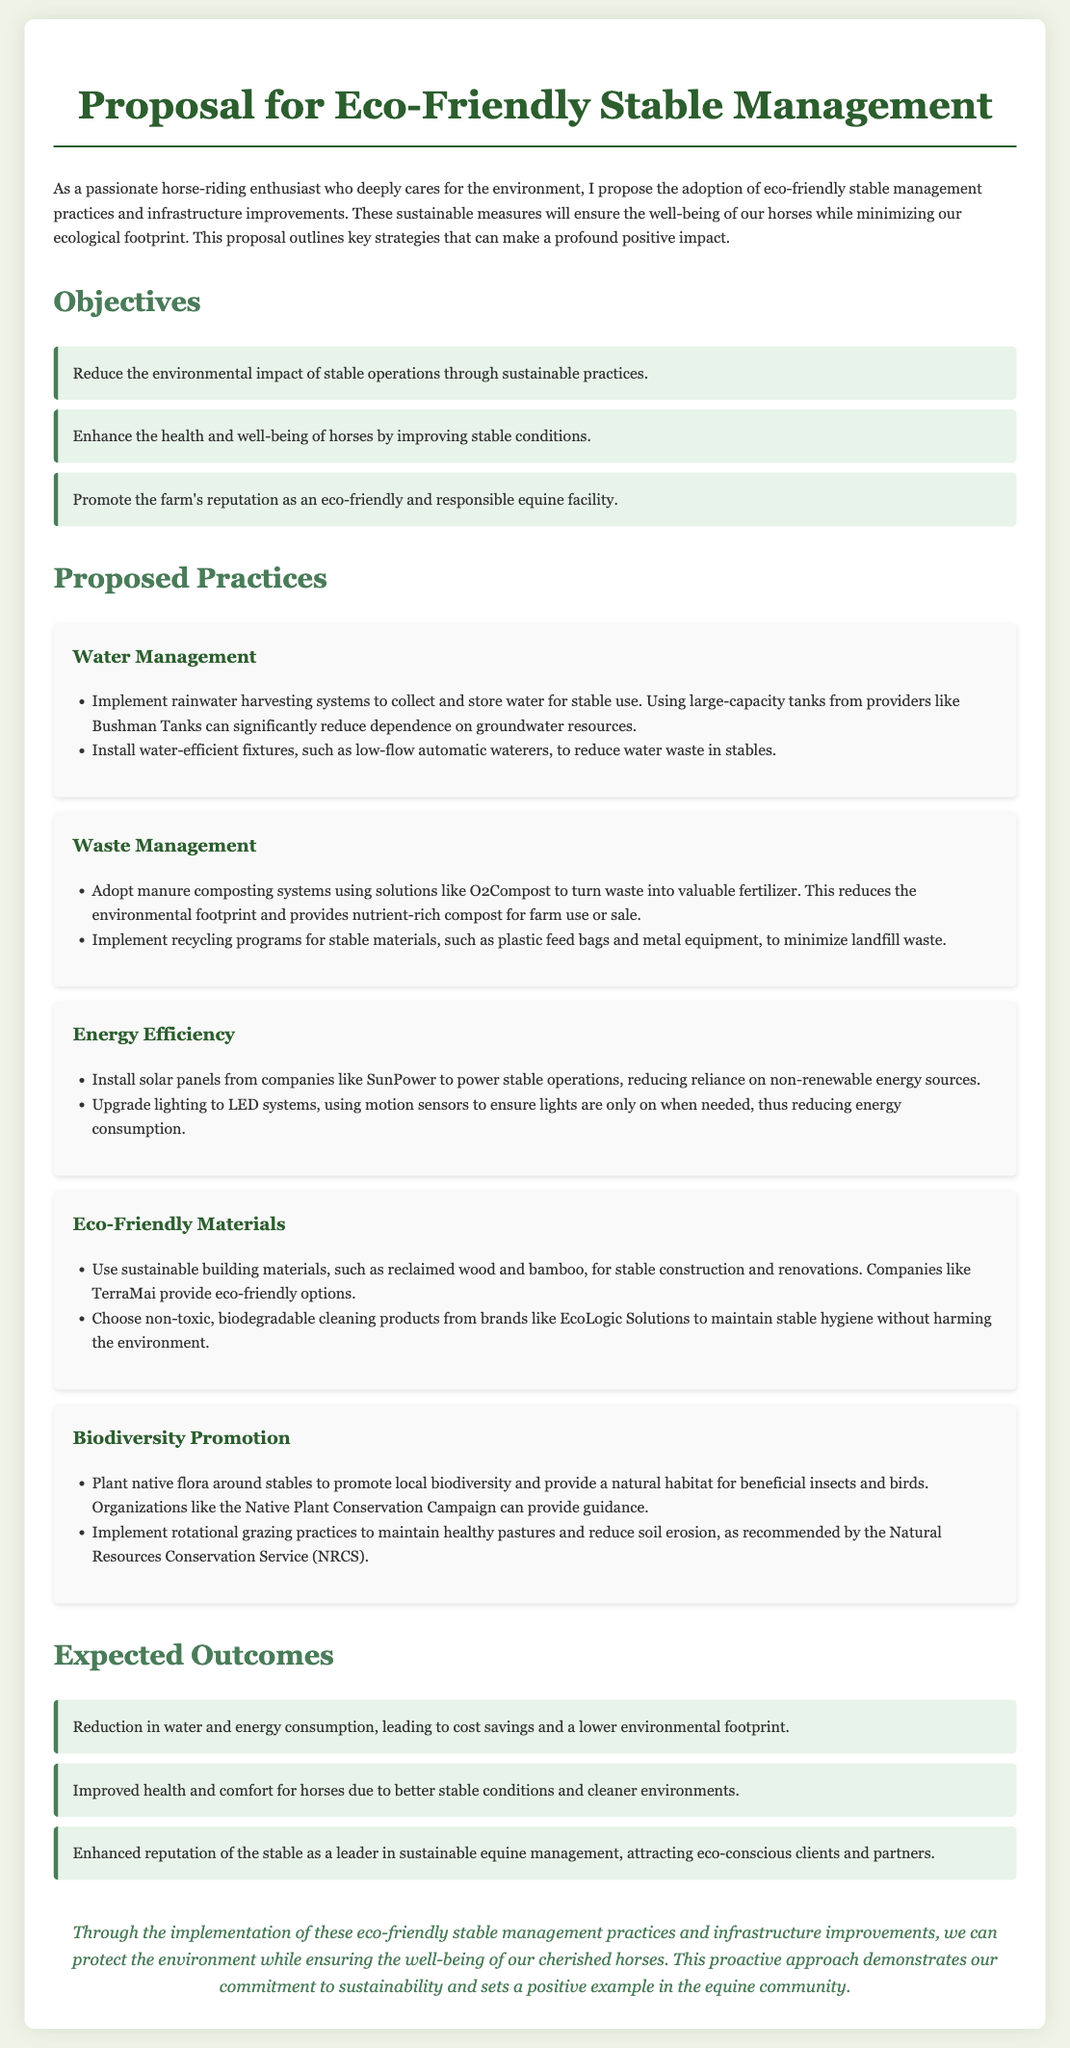What is the main purpose of the proposal? The main purpose outlined in the document is the adoption of eco-friendly stable management practices and infrastructure improvements.
Answer: Eco-friendly stable management practices and infrastructure improvements What is one of the objectives of the proposal? One of the objectives mentioned is to enhance the health and well-being of horses by improving stable conditions.
Answer: Enhance the health and well-being of horses Which company is mentioned for water management solutions? The document states that large-capacity tanks from providers like Bushman Tanks can significantly reduce dependence on groundwater resources.
Answer: Bushman Tanks What type of energy solution is proposed for the stable? The proposal includes the installation of solar panels to power stable operations.
Answer: Solar panels How many proposed practices are listed in the document? The document outlines five proposed practices for eco-friendly stable management.
Answer: Five What is one expected outcome of the proposed practices? One expected outcome is the improved health and comfort for horses due to better stable conditions.
Answer: Improved health and comfort for horses What type of materials does the proposal suggest using for stable construction? The proposal recommends using sustainable building materials, such as reclaimed wood and bamboo.
Answer: Sustainable building materials Which organization provides guidance for planting native flora? The Native Plant Conservation Campaign is mentioned as an organization that can provide guidance for planting native flora.
Answer: Native Plant Conservation Campaign What is the conclusion of the proposal? The conclusion emphasizes the commitment to sustainability while ensuring the well-being of horses.
Answer: Commitment to sustainability and well-being of horses 